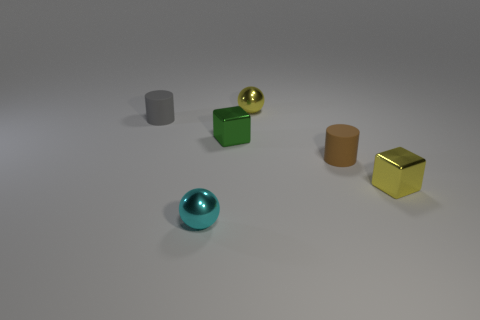Add 3 tiny yellow metal cubes. How many objects exist? 9 Subtract all balls. How many objects are left? 4 Subtract all tiny yellow rubber cylinders. Subtract all small gray matte cylinders. How many objects are left? 5 Add 2 small yellow shiny balls. How many small yellow shiny balls are left? 3 Add 6 spheres. How many spheres exist? 8 Subtract 0 red balls. How many objects are left? 6 